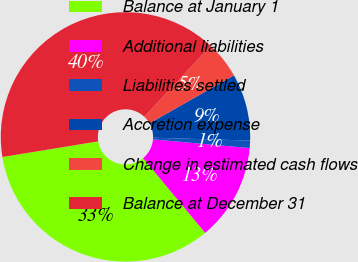Convert chart to OTSL. <chart><loc_0><loc_0><loc_500><loc_500><pie_chart><fcel>Balance at January 1<fcel>Additional liabilities<fcel>Liabilities settled<fcel>Accretion expense<fcel>Change in estimated cash flows<fcel>Balance at December 31<nl><fcel>33.46%<fcel>12.54%<fcel>0.96%<fcel>8.68%<fcel>4.82%<fcel>39.55%<nl></chart> 